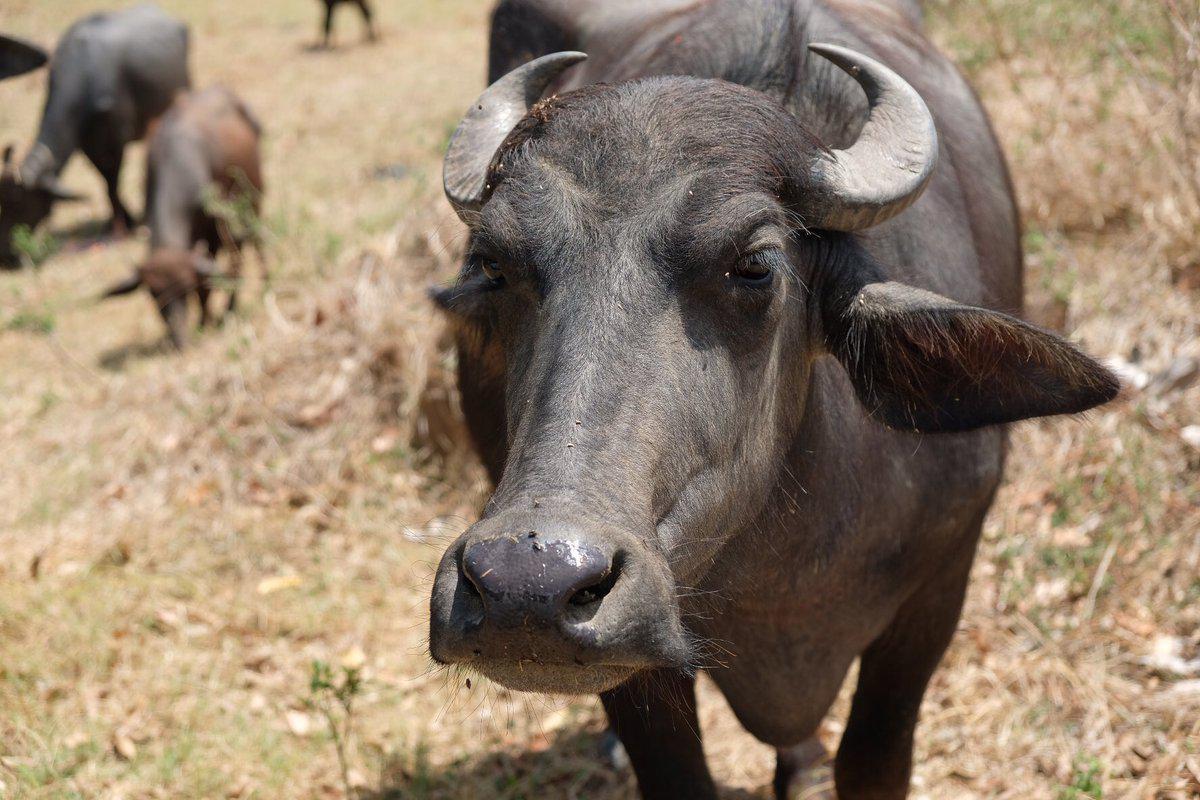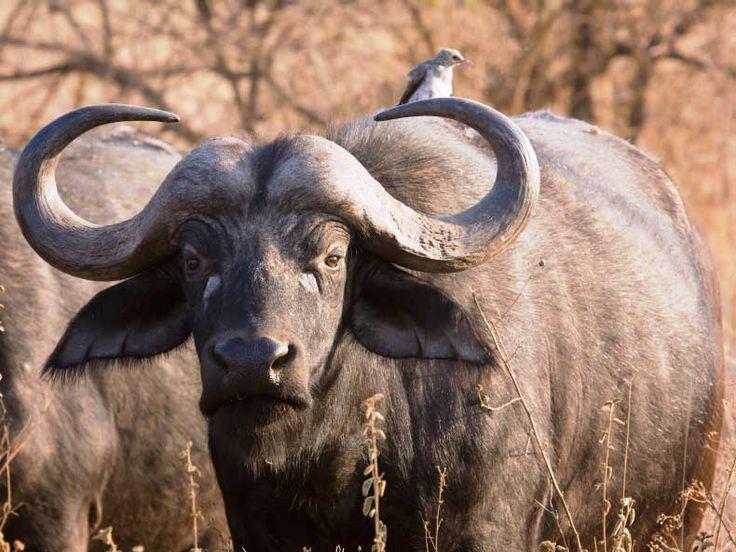The first image is the image on the left, the second image is the image on the right. Assess this claim about the two images: "The left image includes a forward-facing buffalo with other buffalo in the background at the left, and the right image shows a buffalo with a different type of animal on its back.". Correct or not? Answer yes or no. Yes. The first image is the image on the left, the second image is the image on the right. Considering the images on both sides, is "In at least one image there is a single round horned ox standing next to it brown cafe" valid? Answer yes or no. No. 